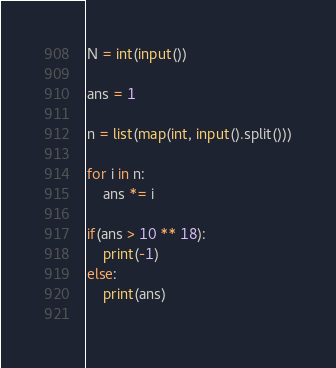<code> <loc_0><loc_0><loc_500><loc_500><_Python_>N = int(input())

ans = 1

n = list(map(int, input().split()))

for i in n:
    ans *= i

if(ans > 10 ** 18):
    print(-1)
else:
    print(ans)
    </code> 